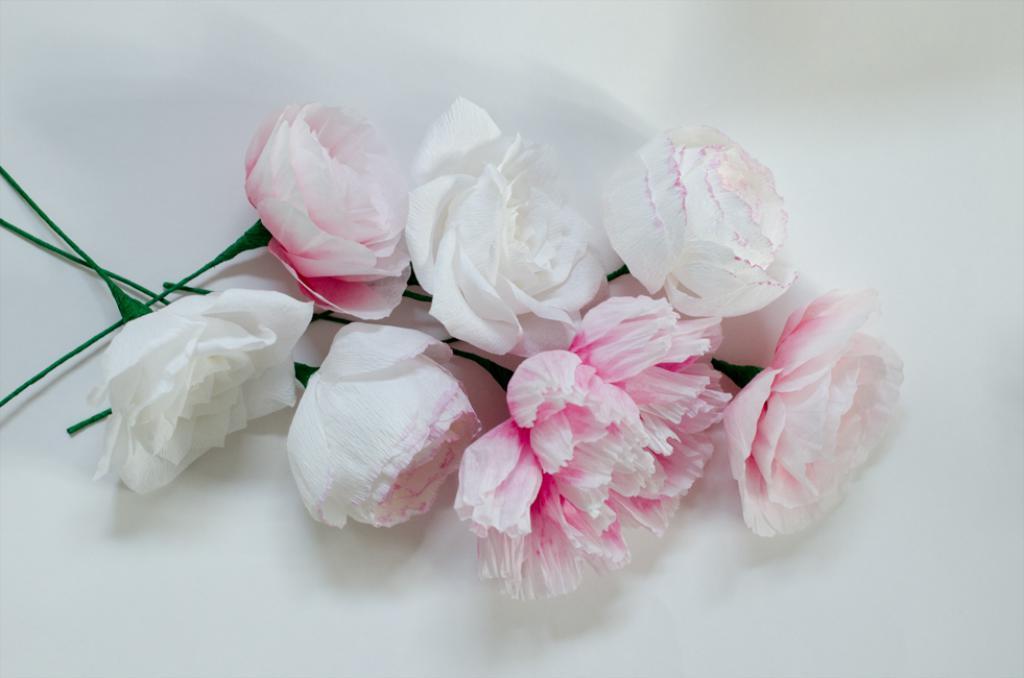Please provide a concise description of this image. In this image I can see the flowers on the white color surface. These flowers are in white and pink color. 